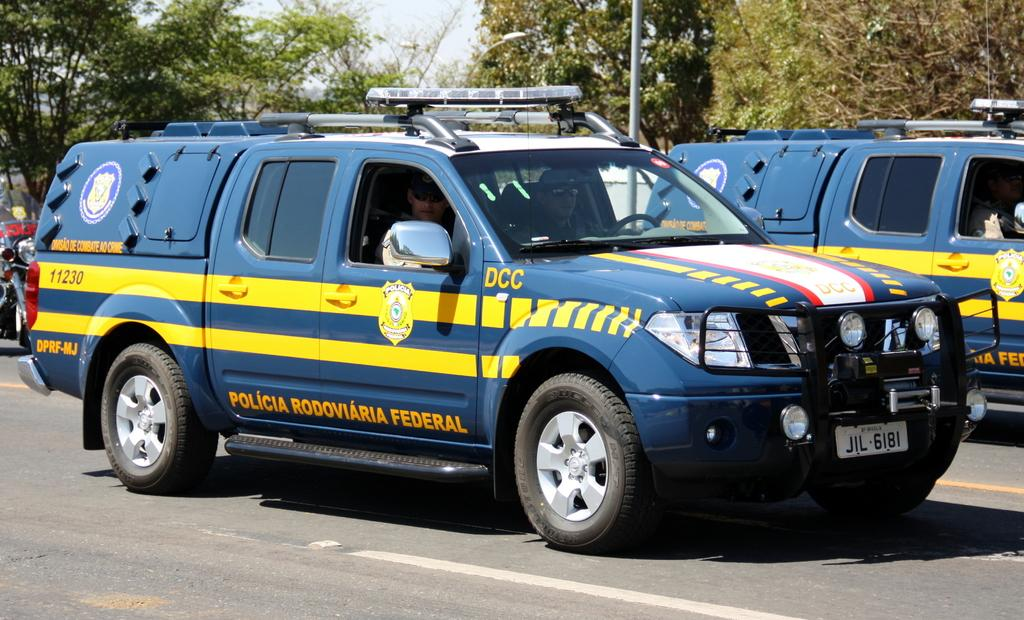What can be seen on the road in the image? There are vehicles on the road in the image. How many people are visible in the image? Two persons are sitting in the image. What type of natural elements can be seen in the image? There are trees in the image. What type of potato is being used as a decoration in the image? There is no potato present in the image. How many yams are visible in the image? There are no yams present in the image. 